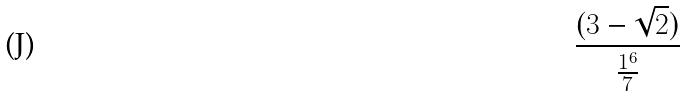<formula> <loc_0><loc_0><loc_500><loc_500>\frac { ( 3 - \sqrt { 2 } ) } { \frac { 1 ^ { 6 } } { 7 } }</formula> 